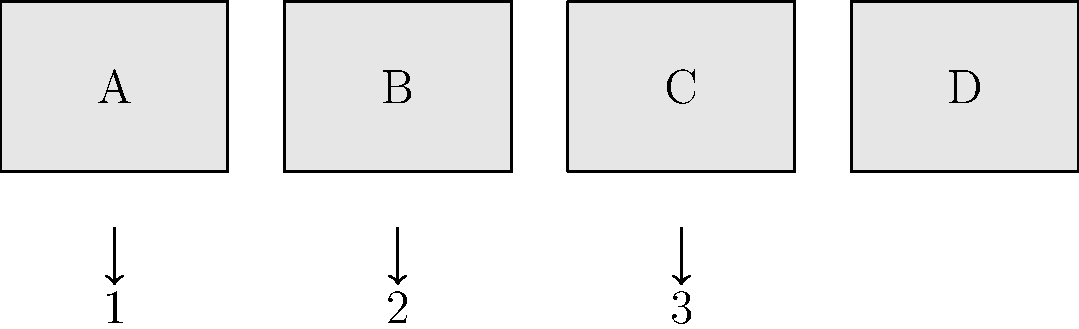As a film enthusiast, imagine you're creating a storyboard for a short basketball training montage. The scenes are out of order and need to be mentally rearranged to create a coherent sequence. Given the storyboard panels A, B, C, and D, what is the correct order of scenes to show a player's progression from practice to game-winning shot? To solve this spatial intelligence problem, we need to mentally visualize and arrange the storyboard panels in a logical sequence for a basketball training montage. Let's break it down step-by-step:

1. Analyze each scene:
   A: Player practicing alone in a gym
   B: Player joining a team practice
   C: Player in a game situation
   D: Player making a game-winning shot

2. Consider the natural progression of a player's development:
   - Individual practice comes first
   - Team practice follows individual training
   - Game situations come after sufficient practice
   - A game-winning shot would be the climax of the sequence

3. Apply basketball training knowledge:
   - Skills are developed through individual practice
   - Team dynamics are learned in group settings
   - Game experience is gained after mastering fundamentals
   - Clutch performance in games is the ultimate goal

4. Arrange the scenes in the most logical order:
   1. A (Individual practice)
   2. B (Team practice)
   3. C (Game situation)
   4. D (Game-winning shot)

This sequence shows a clear progression from solo training to the pinnacle of basketball performance, creating a coherent and compelling narrative for the montage.
Answer: A, B, C, D 